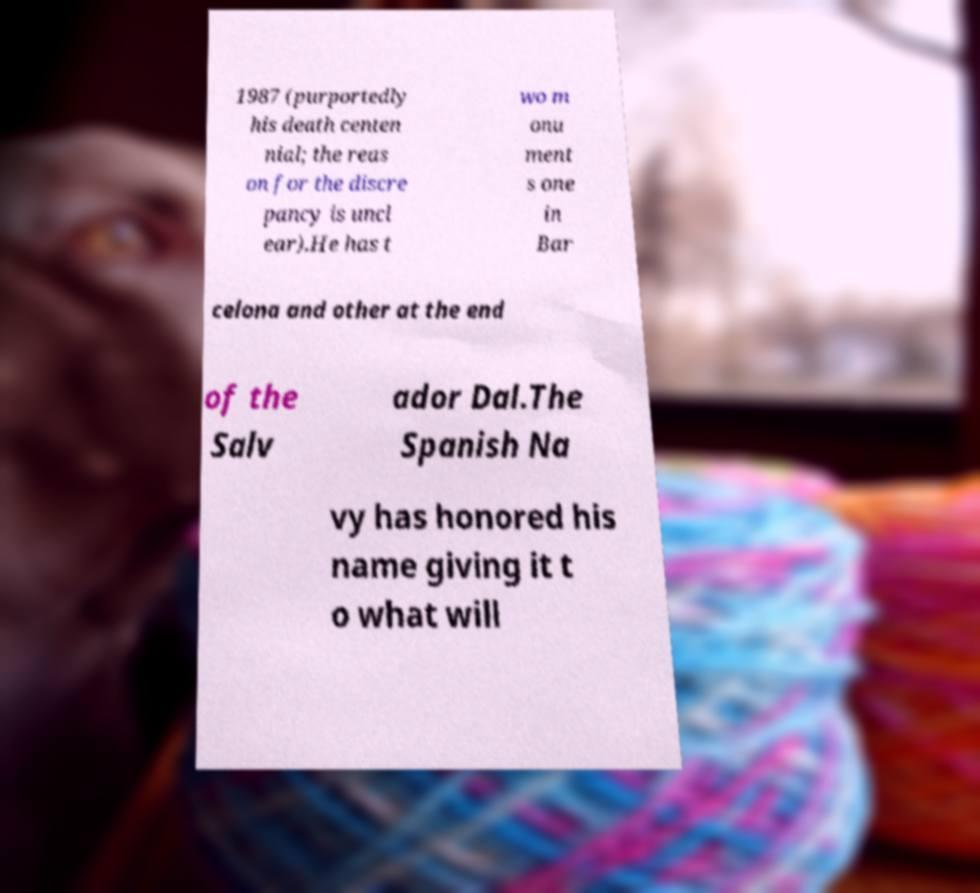Please read and relay the text visible in this image. What does it say? 1987 (purportedly his death centen nial; the reas on for the discre pancy is uncl ear).He has t wo m onu ment s one in Bar celona and other at the end of the Salv ador Dal.The Spanish Na vy has honored his name giving it t o what will 